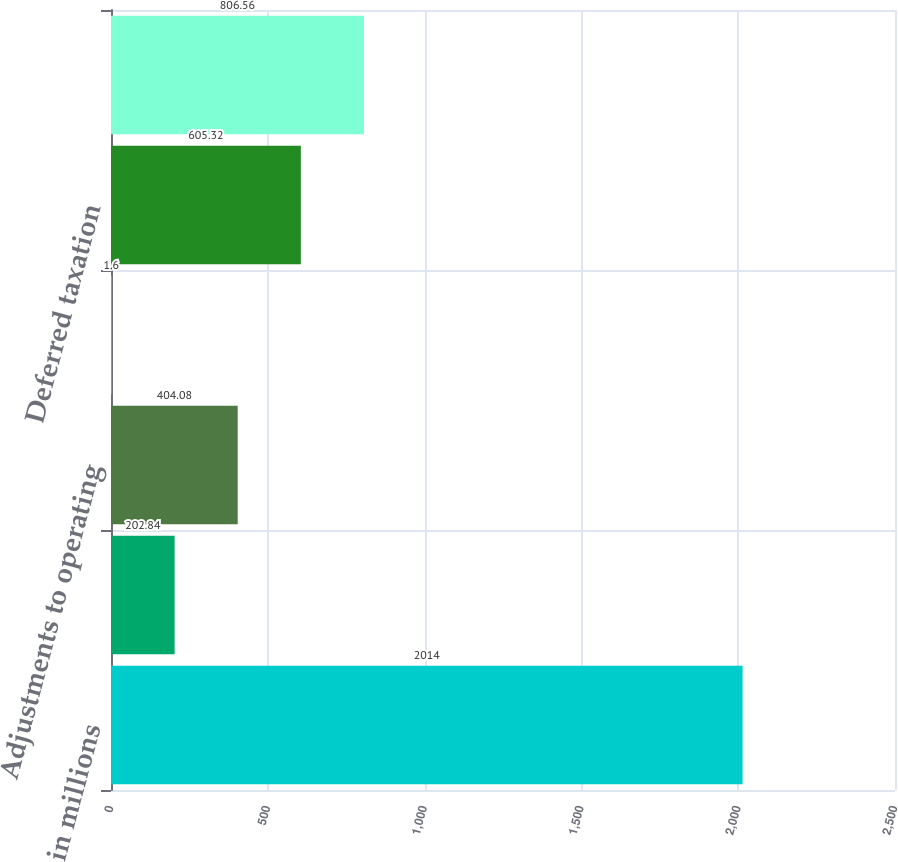<chart> <loc_0><loc_0><loc_500><loc_500><bar_chart><fcel>in millions<fcel>Intangible amortization<fcel>Adjustments to operating<fcel>Taxation on amortization<fcel>Deferred taxation<fcel>Adjustments to net income<nl><fcel>2014<fcel>202.84<fcel>404.08<fcel>1.6<fcel>605.32<fcel>806.56<nl></chart> 